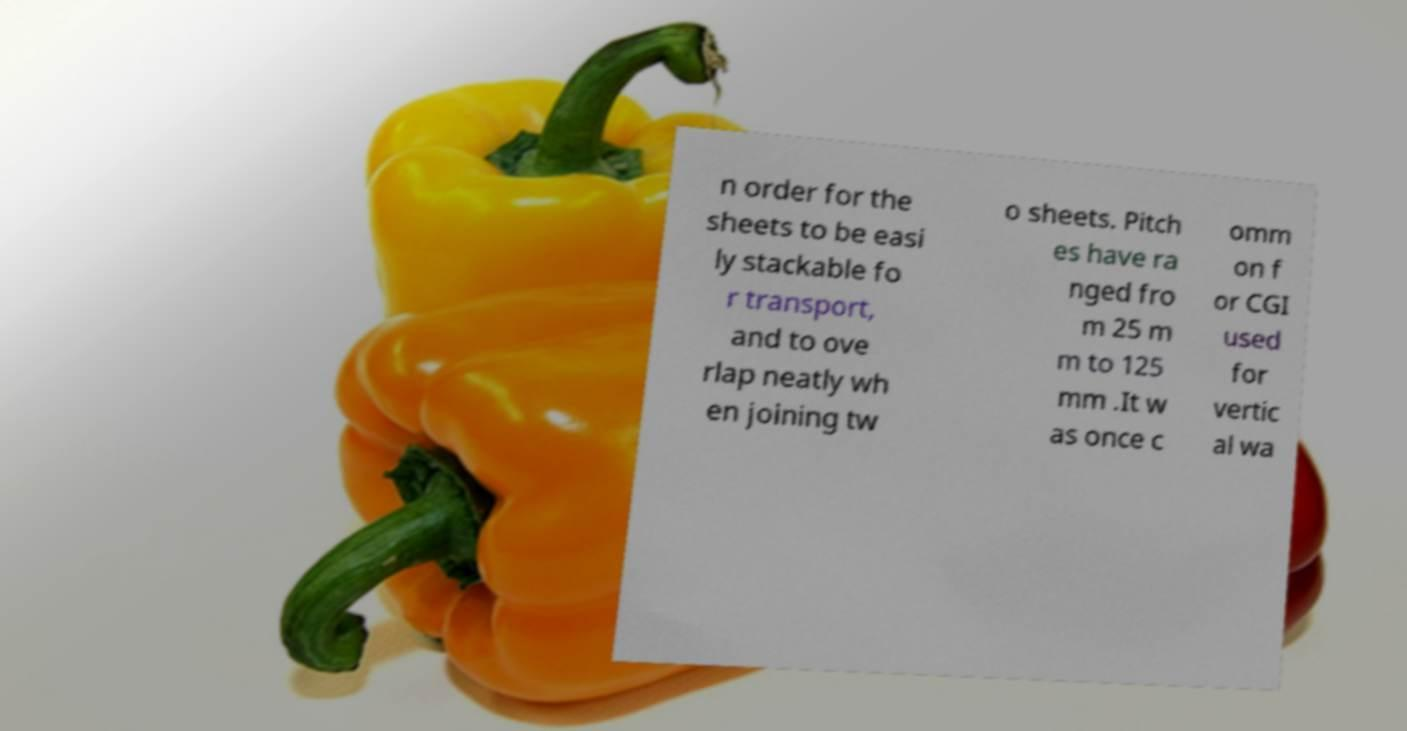Please read and relay the text visible in this image. What does it say? n order for the sheets to be easi ly stackable fo r transport, and to ove rlap neatly wh en joining tw o sheets. Pitch es have ra nged fro m 25 m m to 125 mm .It w as once c omm on f or CGI used for vertic al wa 